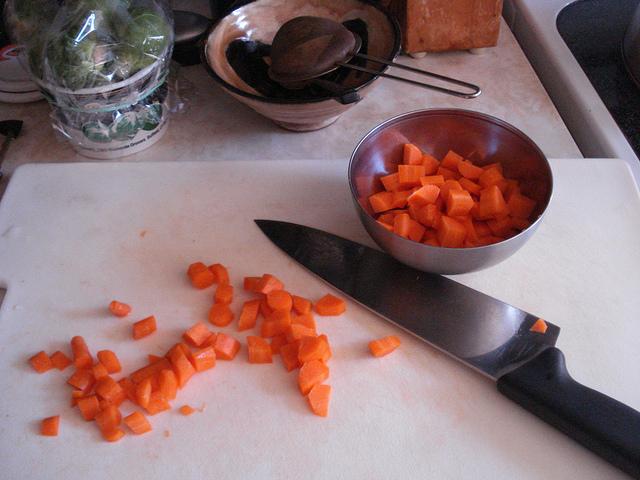Are the carrots diced or cut long ways?
Write a very short answer. Diced. Where is the chef knife?
Quick response, please. On cutting board. What vegetable is this?
Answer briefly. Carrot. 